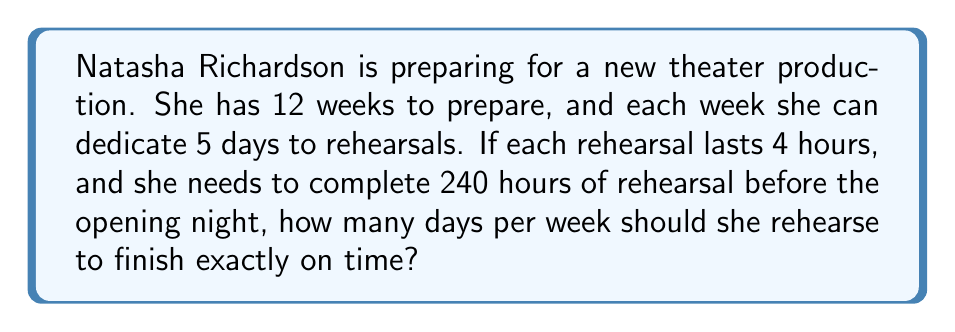Provide a solution to this math problem. Let's approach this problem step by step:

1. First, let's identify the given information:
   - Total preparation time: 12 weeks
   - Maximum rehearsal days per week: 5 days
   - Duration of each rehearsal: 4 hours
   - Total required rehearsal time: 240 hours

2. Let's define a variable:
   Let $x$ be the number of days per week Natasha should rehearse.

3. Now, we can set up an equation:
   - Total rehearsal hours = Number of weeks × Days per week × Hours per rehearsal
   - $240 = 12 \times x \times 4$

4. Simplify the equation:
   $240 = 48x$

5. Solve for $x$:
   $$\begin{align}
   240 &= 48x \\
   \frac{240}{48} &= x \\
   5 &= x
   \end{align}$$

6. Check if the solution makes sense:
   - 5 days is within the maximum 5 days per week given in the problem.
   - Total rehearsal time: $12 \text{ weeks} \times 5 \text{ days/week} \times 4 \text{ hours/day} = 240 \text{ hours}$

Therefore, Natasha should rehearse 5 days per week to complete exactly 240 hours of rehearsal in 12 weeks.
Answer: $5$ days per week 